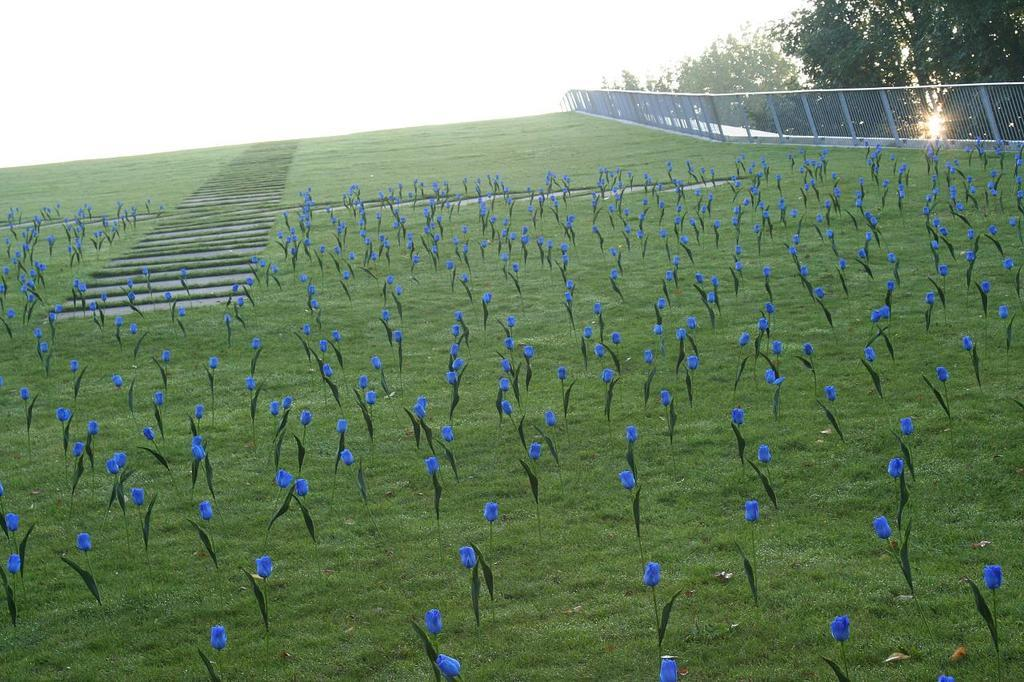What type of vegetation can be seen on the ground in the image? There are flowers on the ground in the image. What can be seen on the right side of the image? There are trees and fencing on the right side of the image. What is visible in the background of the image? The sky is visible in the background of the image. What word is written on the pen in the image? There is no pen present in the image, so it is not possible to determine what word might be written on it. 